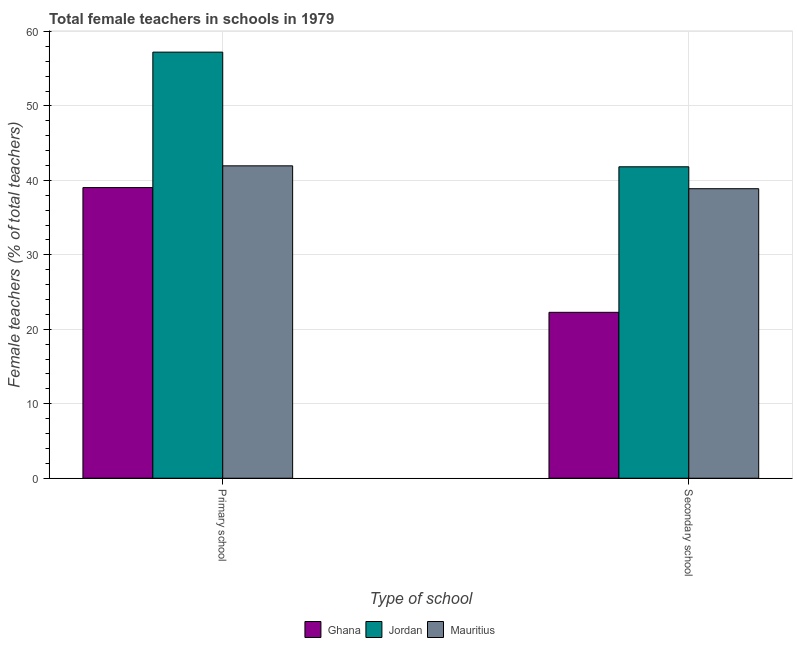How many different coloured bars are there?
Ensure brevity in your answer.  3. Are the number of bars on each tick of the X-axis equal?
Give a very brief answer. Yes. How many bars are there on the 1st tick from the left?
Provide a short and direct response. 3. What is the label of the 1st group of bars from the left?
Your response must be concise. Primary school. What is the percentage of female teachers in primary schools in Jordan?
Ensure brevity in your answer.  57.22. Across all countries, what is the maximum percentage of female teachers in secondary schools?
Ensure brevity in your answer.  41.82. Across all countries, what is the minimum percentage of female teachers in primary schools?
Keep it short and to the point. 39.03. In which country was the percentage of female teachers in secondary schools maximum?
Ensure brevity in your answer.  Jordan. What is the total percentage of female teachers in primary schools in the graph?
Your answer should be very brief. 138.21. What is the difference between the percentage of female teachers in primary schools in Ghana and that in Jordan?
Provide a short and direct response. -18.19. What is the difference between the percentage of female teachers in primary schools in Ghana and the percentage of female teachers in secondary schools in Mauritius?
Offer a very short reply. 0.15. What is the average percentage of female teachers in primary schools per country?
Offer a terse response. 46.07. What is the difference between the percentage of female teachers in primary schools and percentage of female teachers in secondary schools in Jordan?
Provide a succinct answer. 15.4. What is the ratio of the percentage of female teachers in primary schools in Ghana to that in Jordan?
Provide a short and direct response. 0.68. In how many countries, is the percentage of female teachers in primary schools greater than the average percentage of female teachers in primary schools taken over all countries?
Give a very brief answer. 1. What does the 3rd bar from the left in Primary school represents?
Offer a terse response. Mauritius. What does the 2nd bar from the right in Primary school represents?
Your answer should be very brief. Jordan. How many bars are there?
Keep it short and to the point. 6. Are all the bars in the graph horizontal?
Offer a terse response. No. How many countries are there in the graph?
Make the answer very short. 3. Are the values on the major ticks of Y-axis written in scientific E-notation?
Your response must be concise. No. Where does the legend appear in the graph?
Offer a very short reply. Bottom center. How many legend labels are there?
Give a very brief answer. 3. What is the title of the graph?
Offer a very short reply. Total female teachers in schools in 1979. What is the label or title of the X-axis?
Your response must be concise. Type of school. What is the label or title of the Y-axis?
Ensure brevity in your answer.  Female teachers (% of total teachers). What is the Female teachers (% of total teachers) in Ghana in Primary school?
Your answer should be very brief. 39.03. What is the Female teachers (% of total teachers) in Jordan in Primary school?
Provide a succinct answer. 57.22. What is the Female teachers (% of total teachers) in Mauritius in Primary school?
Your answer should be compact. 41.95. What is the Female teachers (% of total teachers) of Ghana in Secondary school?
Give a very brief answer. 22.28. What is the Female teachers (% of total teachers) of Jordan in Secondary school?
Your response must be concise. 41.82. What is the Female teachers (% of total teachers) in Mauritius in Secondary school?
Ensure brevity in your answer.  38.88. Across all Type of school, what is the maximum Female teachers (% of total teachers) of Ghana?
Make the answer very short. 39.03. Across all Type of school, what is the maximum Female teachers (% of total teachers) in Jordan?
Provide a succinct answer. 57.22. Across all Type of school, what is the maximum Female teachers (% of total teachers) in Mauritius?
Make the answer very short. 41.95. Across all Type of school, what is the minimum Female teachers (% of total teachers) of Ghana?
Give a very brief answer. 22.28. Across all Type of school, what is the minimum Female teachers (% of total teachers) of Jordan?
Give a very brief answer. 41.82. Across all Type of school, what is the minimum Female teachers (% of total teachers) of Mauritius?
Your answer should be compact. 38.88. What is the total Female teachers (% of total teachers) of Ghana in the graph?
Provide a short and direct response. 61.31. What is the total Female teachers (% of total teachers) in Jordan in the graph?
Offer a terse response. 99.05. What is the total Female teachers (% of total teachers) of Mauritius in the graph?
Offer a terse response. 80.83. What is the difference between the Female teachers (% of total teachers) of Ghana in Primary school and that in Secondary school?
Your response must be concise. 16.75. What is the difference between the Female teachers (% of total teachers) in Jordan in Primary school and that in Secondary school?
Your answer should be compact. 15.4. What is the difference between the Female teachers (% of total teachers) of Mauritius in Primary school and that in Secondary school?
Provide a short and direct response. 3.07. What is the difference between the Female teachers (% of total teachers) in Ghana in Primary school and the Female teachers (% of total teachers) in Jordan in Secondary school?
Give a very brief answer. -2.79. What is the difference between the Female teachers (% of total teachers) in Ghana in Primary school and the Female teachers (% of total teachers) in Mauritius in Secondary school?
Offer a terse response. 0.15. What is the difference between the Female teachers (% of total teachers) in Jordan in Primary school and the Female teachers (% of total teachers) in Mauritius in Secondary school?
Make the answer very short. 18.34. What is the average Female teachers (% of total teachers) of Ghana per Type of school?
Ensure brevity in your answer.  30.66. What is the average Female teachers (% of total teachers) in Jordan per Type of school?
Give a very brief answer. 49.52. What is the average Female teachers (% of total teachers) of Mauritius per Type of school?
Offer a terse response. 40.42. What is the difference between the Female teachers (% of total teachers) of Ghana and Female teachers (% of total teachers) of Jordan in Primary school?
Offer a terse response. -18.19. What is the difference between the Female teachers (% of total teachers) in Ghana and Female teachers (% of total teachers) in Mauritius in Primary school?
Provide a short and direct response. -2.92. What is the difference between the Female teachers (% of total teachers) in Jordan and Female teachers (% of total teachers) in Mauritius in Primary school?
Make the answer very short. 15.27. What is the difference between the Female teachers (% of total teachers) of Ghana and Female teachers (% of total teachers) of Jordan in Secondary school?
Ensure brevity in your answer.  -19.54. What is the difference between the Female teachers (% of total teachers) in Ghana and Female teachers (% of total teachers) in Mauritius in Secondary school?
Keep it short and to the point. -16.6. What is the difference between the Female teachers (% of total teachers) of Jordan and Female teachers (% of total teachers) of Mauritius in Secondary school?
Ensure brevity in your answer.  2.94. What is the ratio of the Female teachers (% of total teachers) of Ghana in Primary school to that in Secondary school?
Ensure brevity in your answer.  1.75. What is the ratio of the Female teachers (% of total teachers) of Jordan in Primary school to that in Secondary school?
Give a very brief answer. 1.37. What is the ratio of the Female teachers (% of total teachers) in Mauritius in Primary school to that in Secondary school?
Your response must be concise. 1.08. What is the difference between the highest and the second highest Female teachers (% of total teachers) of Ghana?
Your answer should be compact. 16.75. What is the difference between the highest and the second highest Female teachers (% of total teachers) of Jordan?
Make the answer very short. 15.4. What is the difference between the highest and the second highest Female teachers (% of total teachers) in Mauritius?
Make the answer very short. 3.07. What is the difference between the highest and the lowest Female teachers (% of total teachers) in Ghana?
Your response must be concise. 16.75. What is the difference between the highest and the lowest Female teachers (% of total teachers) of Jordan?
Ensure brevity in your answer.  15.4. What is the difference between the highest and the lowest Female teachers (% of total teachers) in Mauritius?
Your answer should be very brief. 3.07. 